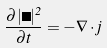<formula> <loc_0><loc_0><loc_500><loc_500>\frac { \partial | \Psi | ^ { 2 } } { \partial t } = - \nabla \cdot j</formula> 